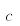Convert formula to latex. <formula><loc_0><loc_0><loc_500><loc_500>c</formula> 